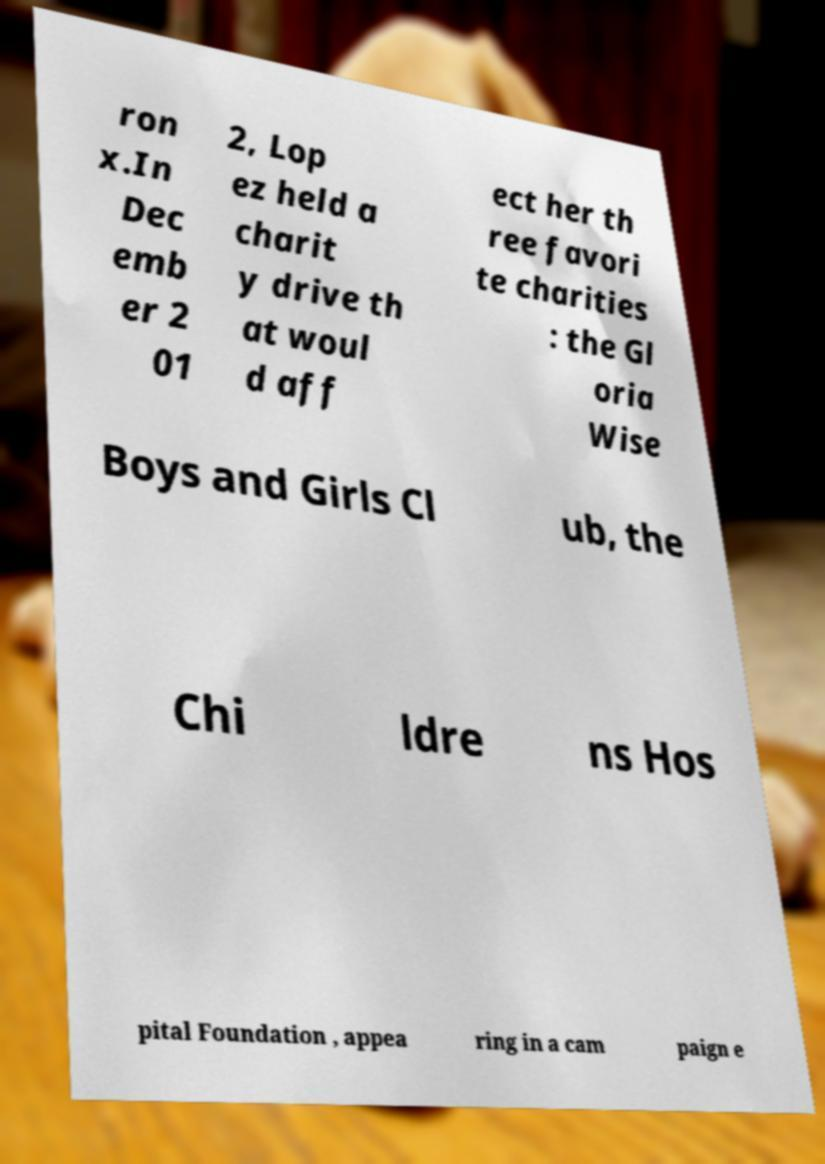What messages or text are displayed in this image? I need them in a readable, typed format. ron x.In Dec emb er 2 01 2, Lop ez held a charit y drive th at woul d aff ect her th ree favori te charities : the Gl oria Wise Boys and Girls Cl ub, the Chi ldre ns Hos pital Foundation , appea ring in a cam paign e 